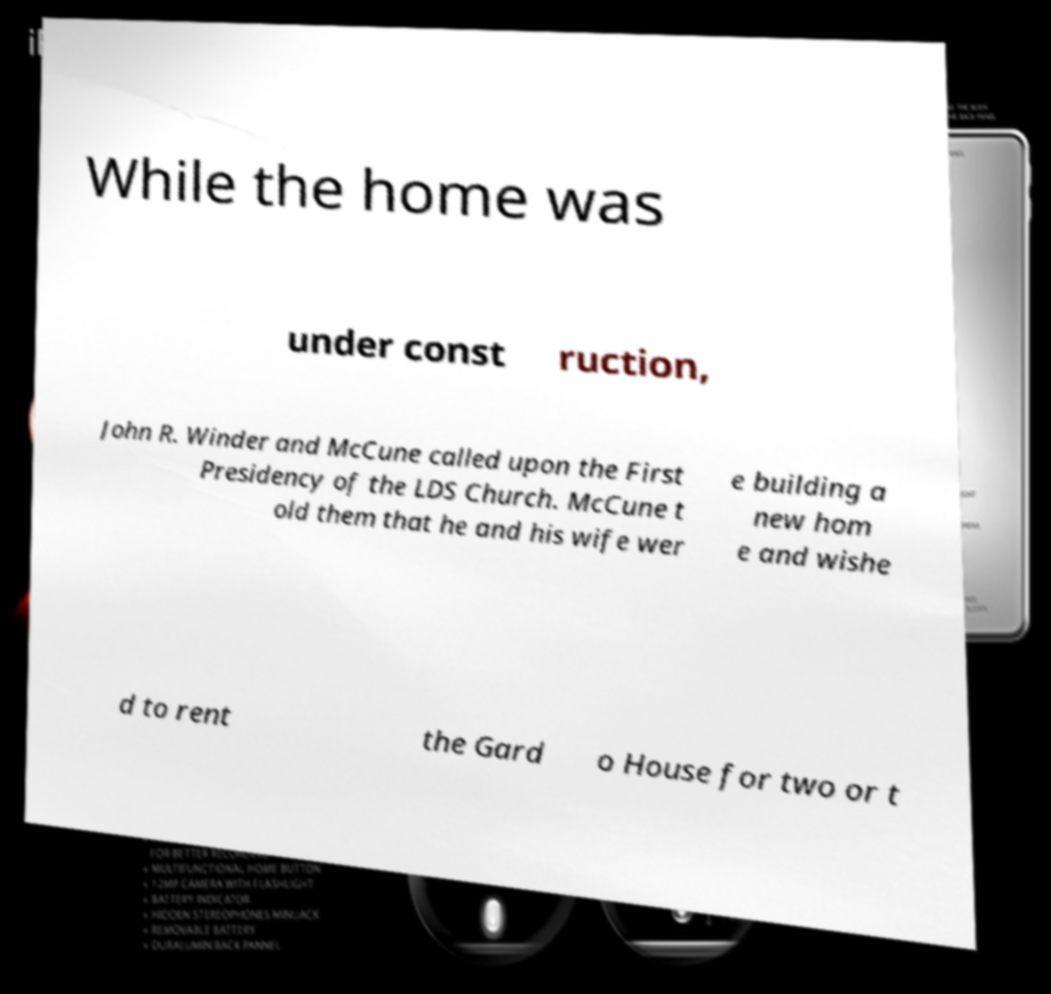Can you read and provide the text displayed in the image?This photo seems to have some interesting text. Can you extract and type it out for me? While the home was under const ruction, John R. Winder and McCune called upon the First Presidency of the LDS Church. McCune t old them that he and his wife wer e building a new hom e and wishe d to rent the Gard o House for two or t 